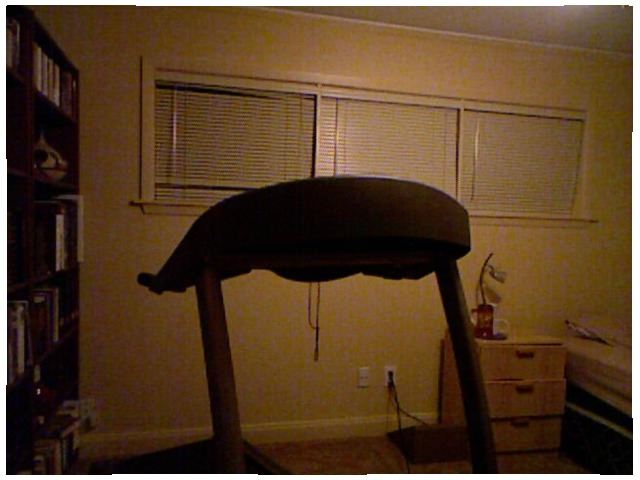<image>
Is there a treadmill in front of the blinds? Yes. The treadmill is positioned in front of the blinds, appearing closer to the camera viewpoint. 